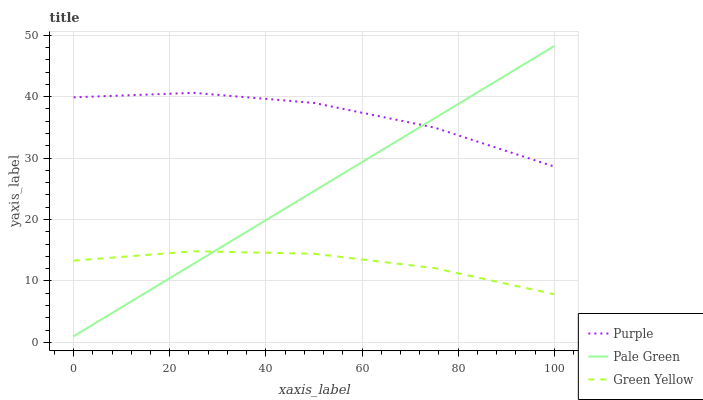Does Green Yellow have the minimum area under the curve?
Answer yes or no. Yes. Does Purple have the maximum area under the curve?
Answer yes or no. Yes. Does Pale Green have the minimum area under the curve?
Answer yes or no. No. Does Pale Green have the maximum area under the curve?
Answer yes or no. No. Is Pale Green the smoothest?
Answer yes or no. Yes. Is Purple the roughest?
Answer yes or no. Yes. Is Green Yellow the smoothest?
Answer yes or no. No. Is Green Yellow the roughest?
Answer yes or no. No. Does Pale Green have the lowest value?
Answer yes or no. Yes. Does Green Yellow have the lowest value?
Answer yes or no. No. Does Pale Green have the highest value?
Answer yes or no. Yes. Does Green Yellow have the highest value?
Answer yes or no. No. Is Green Yellow less than Purple?
Answer yes or no. Yes. Is Purple greater than Green Yellow?
Answer yes or no. Yes. Does Pale Green intersect Green Yellow?
Answer yes or no. Yes. Is Pale Green less than Green Yellow?
Answer yes or no. No. Is Pale Green greater than Green Yellow?
Answer yes or no. No. Does Green Yellow intersect Purple?
Answer yes or no. No. 